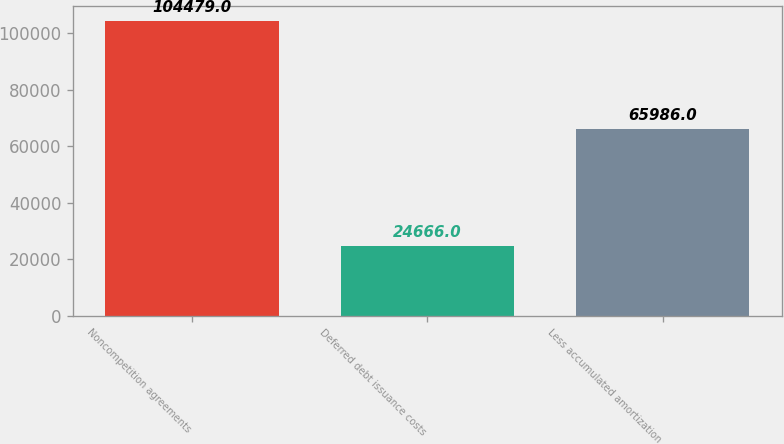<chart> <loc_0><loc_0><loc_500><loc_500><bar_chart><fcel>Noncompetition agreements<fcel>Deferred debt issuance costs<fcel>Less accumulated amortization<nl><fcel>104479<fcel>24666<fcel>65986<nl></chart> 